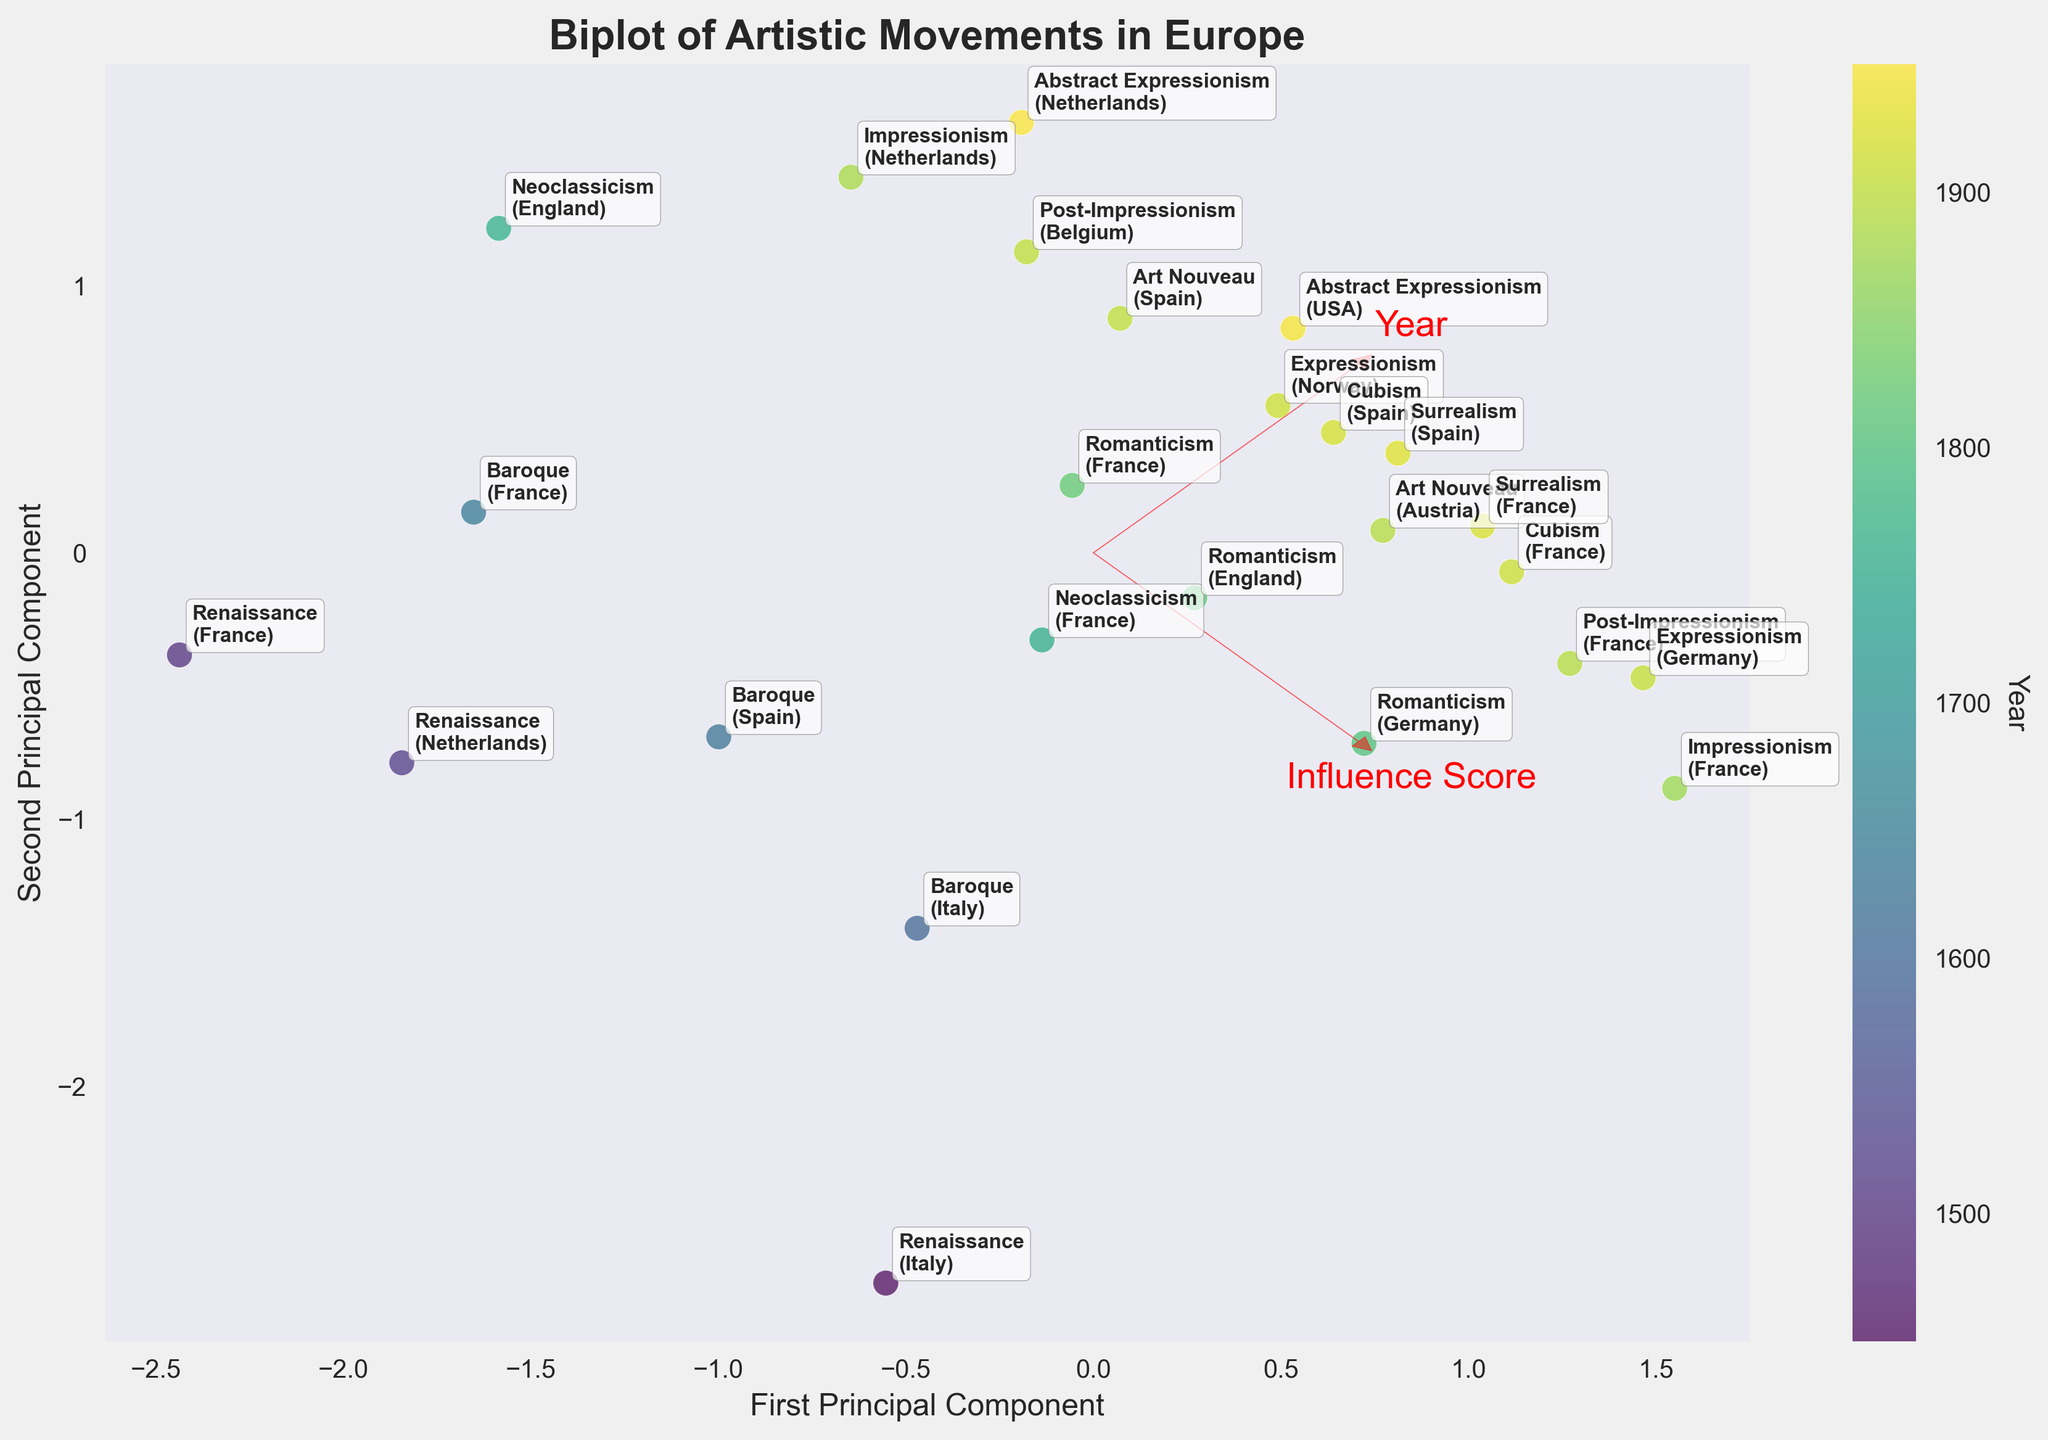What does the color of the data points represent? The color of the data points represents the year of the artistic movement, with a gradient from earlier years (darker colors) to later years (lighter colors).
Answer: Year What is the title of the figure? The title is displayed at the top of the figure above the plot area.
Answer: Biplot of Artistic Movements in Europe Which artistic movement from Germany has the highest influence score? Locate the data points labeled with German artistic movements and compare their Influence Scores displayed near the point.
Answer: Expressionism Which country has the most data points in the plot? By counting the labels for each data point associated with a country, we see that France has the most entries.
Answer: France How does the Renaissance movement in Italy compare to the Romanticism movement in England regarding the first principal component? Comparing the positions of the respective data points along the x-axis (first principal component), the Renaissance in Italy has a more positive value than Romanticism in England.
Answer: Renaissance in Italy has a higher value What are the two features depicted by the vectors in the plot? The plot shows two vectors labeled "Year" and "Influence Score" which indicate the features used for the PCA.
Answer: Year and Influence Score Which artistic movement coincides with the arrow indicating the highest Influence Score? The vector pointing towards the highest Influence Score corresponds to points labeled with high Influence Scores.
Answer: Impressionism in France Compared to Baroque in Italy, does Impressionism in France occur earlier or later based on the year? Observing the color gradient of the data points and the labels, Impressionism in France (1870) is later compared to Baroque in Italy (1600).
Answer: Later Which principal component has a higher impact on the "Influence Score" feature based on the vector orientation? The arrow labeled "Influence Score" points more prominently along the second principal component y-axis.
Answer: Second principal component (y) In which range of years are there no data points from artistic movements originating in Spain? Examination of the color gradient and labels reveals that no Spanish artistic movements are represented between roughly 1725 and 1875.
Answer: 1725-1875 